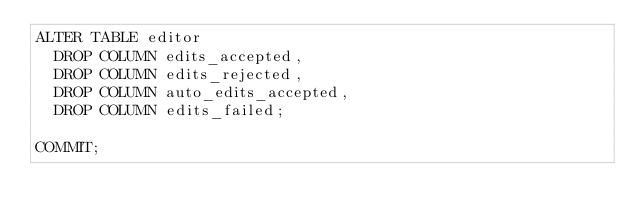<code> <loc_0><loc_0><loc_500><loc_500><_SQL_>ALTER TABLE editor
  DROP COLUMN edits_accepted,
  DROP COLUMN edits_rejected,
  DROP COLUMN auto_edits_accepted,
  DROP COLUMN edits_failed;

COMMIT;
</code> 